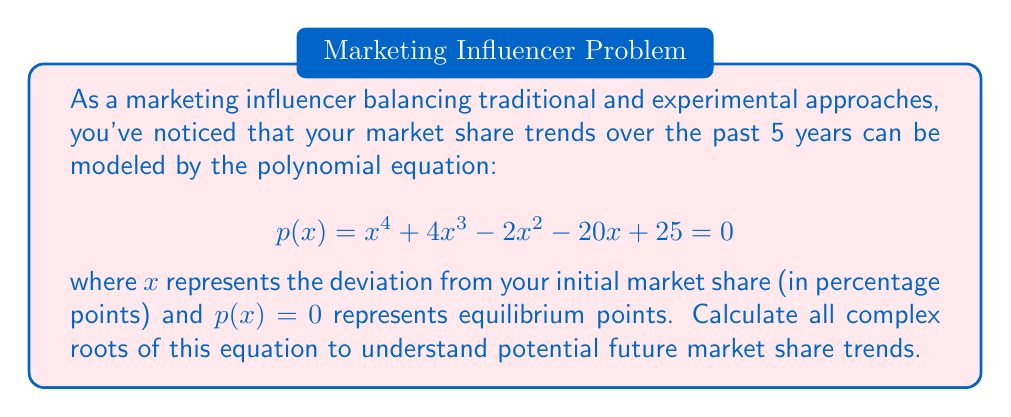Solve this math problem. To solve this quartic equation, we'll use the following steps:

1) First, we notice that this polynomial doesn't have an obvious rational root, so we'll need to use more advanced techniques.

2) We can use Ferrari's method to solve this quartic equation. The first step is to convert it to a depressed quartic by substituting $x = y - 1$:

   $$(y-1)^4 + 4(y-1)^3 - 2(y-1)^2 - 20(y-1) + 25 = 0$$

3) Expanding this:

   $$y^4 - 4y^3 + 6y^2 - 4y + 1 + 4y^3 - 12y^2 + 12y - 4 - 2y^2 + 4y - 2 - 20y + 20 + 25 = 0$$
   $$y^4 - 8y^2 - 8y + 40 = 0$$

4) Now we introduce an auxiliary variable $z$ and rewrite our equation as:

   $$(y^2 + z)^2 = 2zy^2 + 8y + (z^2 - 40)$$

5) For this to be a perfect square, its discriminant must be zero:

   $$(2z)^2 - 4(1)(z^2 - 40) = 0$$
   $$4z^2 - 4z^2 + 160 = 0$$
   $$z^2 = 40$$
   $$z = \pm \sqrt{40} = \pm 2\sqrt{10}$$

6) We choose $z = 2\sqrt{10}$ (either choice leads to the same result). Substituting back:

   $$(y^2 + 2\sqrt{10})^2 = 4\sqrt{10}y^2 + 8y$$

7) Taking the square root of both sides:

   $$y^2 + 2\sqrt{10} = \pm(2\sqrt[4]{10}y + \frac{2}{\sqrt[4]{10}})$$

8) This gives us two quadratic equations:

   $$y^2 - 2\sqrt[4]{10}y + (2\sqrt{10} - \frac{2}{\sqrt[4]{10}}) = 0$$
   $$y^2 + 2\sqrt[4]{10}y + (2\sqrt{10} + \frac{2}{\sqrt[4]{10}}) = 0$$

9) Solving these quadratics using the quadratic formula:

   $$y = \sqrt[4]{10} \pm i\sqrt{2\sqrt{10} - \frac{2}{\sqrt[4]{10}} - \sqrt{10}}$$
   $$y = -\sqrt[4]{10} \pm i\sqrt{2\sqrt{10} + \frac{2}{\sqrt[4]{10}} - \sqrt{10}}$$

10) Remember that $x = y - 1$, so our final solutions are:

    $$x = \sqrt[4]{10} - 1 \pm i\sqrt{2\sqrt{10} - \frac{2}{\sqrt[4]{10}} - \sqrt{10}}$$
    $$x = -\sqrt[4]{10} - 1 \pm i\sqrt{2\sqrt{10} + \frac{2}{\sqrt[4]{10}} - \sqrt{10}}$$
Answer: The four complex roots of the equation are:

$$x_1 = \sqrt[4]{10} - 1 + i\sqrt{2\sqrt{10} - \frac{2}{\sqrt[4]{10}} - \sqrt{10}}$$
$$x_2 = \sqrt[4]{10} - 1 - i\sqrt{2\sqrt{10} - \frac{2}{\sqrt[4]{10}} - \sqrt{10}}$$
$$x_3 = -\sqrt[4]{10} - 1 + i\sqrt{2\sqrt{10} + \frac{2}{\sqrt[4]{10}} - \sqrt{10}}$$
$$x_4 = -\sqrt[4]{10} - 1 - i\sqrt{2\sqrt{10} + \frac{2}{\sqrt[4]{10}} - \sqrt{10}}$$ 